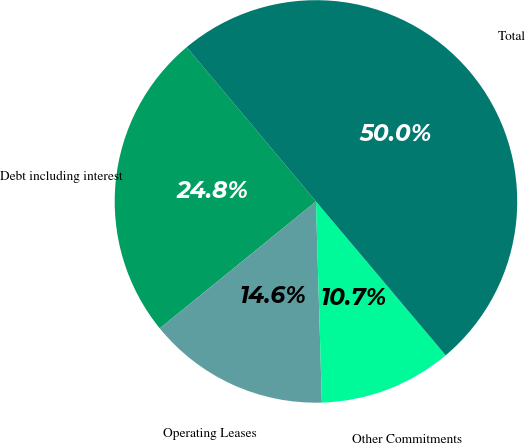<chart> <loc_0><loc_0><loc_500><loc_500><pie_chart><fcel>Debt including interest<fcel>Operating Leases<fcel>Other Commitments<fcel>Total<nl><fcel>24.76%<fcel>14.61%<fcel>10.68%<fcel>49.96%<nl></chart> 